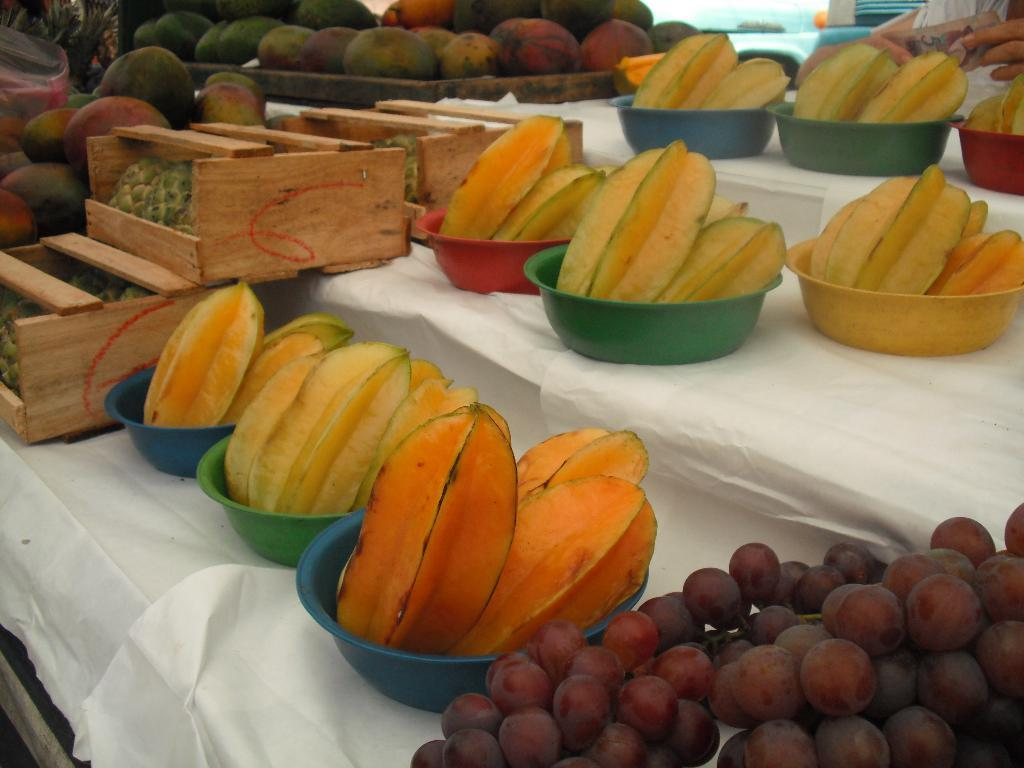What type of containers are present in the image? There are boxes and bowls in the image. What are the containers holding? The boxes and bowls contain fruits. How are the fruits arranged in the image? The fruits are placed on a white color cloth. What is the facial expression of the fruit in the image? There are no faces or expressions on the fruits in the image, as they are simply fruits placed in containers. 